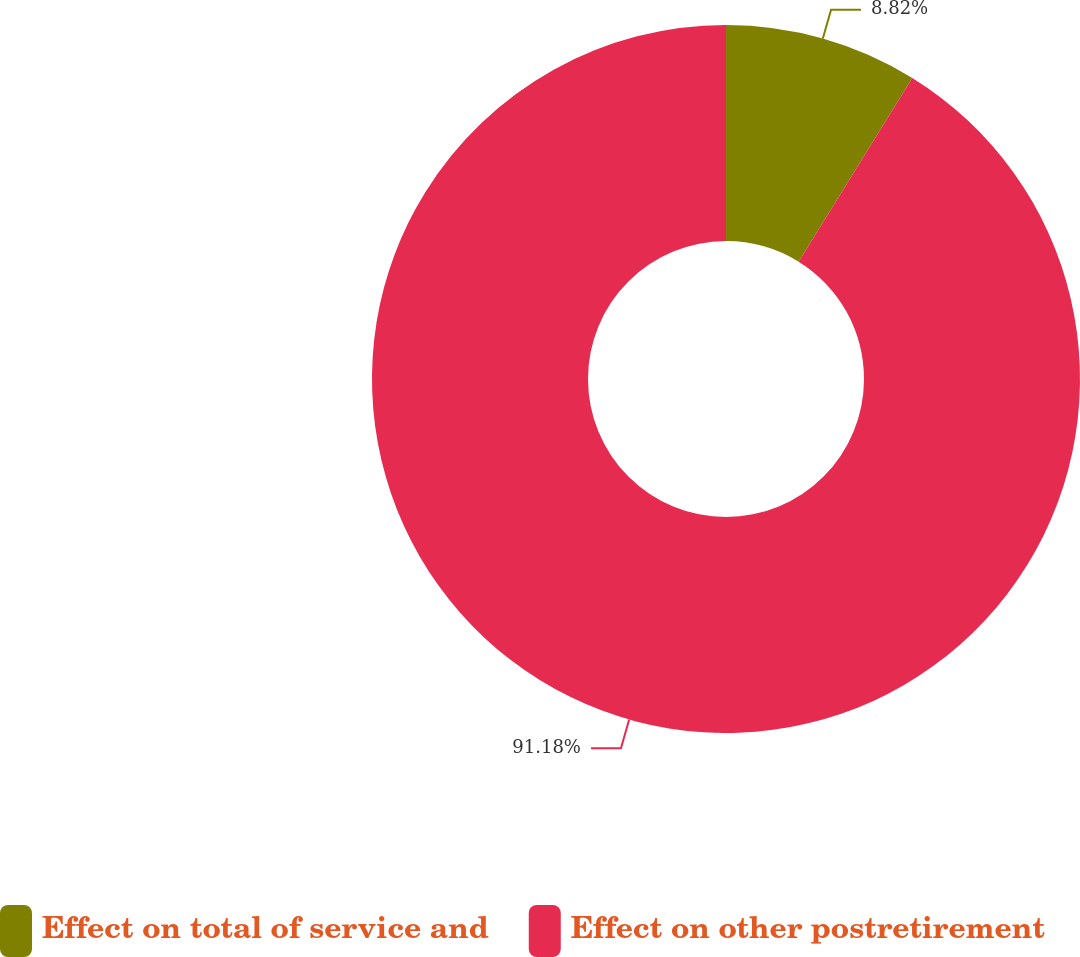<chart> <loc_0><loc_0><loc_500><loc_500><pie_chart><fcel>Effect on total of service and<fcel>Effect on other postretirement<nl><fcel>8.82%<fcel>91.18%<nl></chart> 